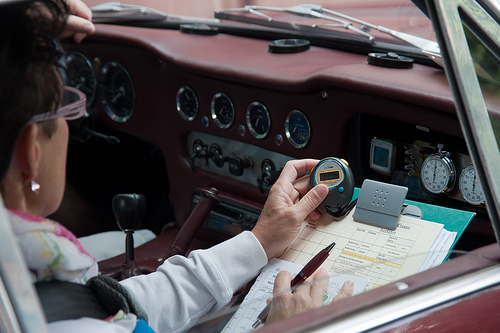Please provide a short description for this region: [0.04, 0.41, 0.1, 0.58]. This zone depicts a delicate silver earring adorned in the right ear of a woman, reflecting a simple yet elegant style. 